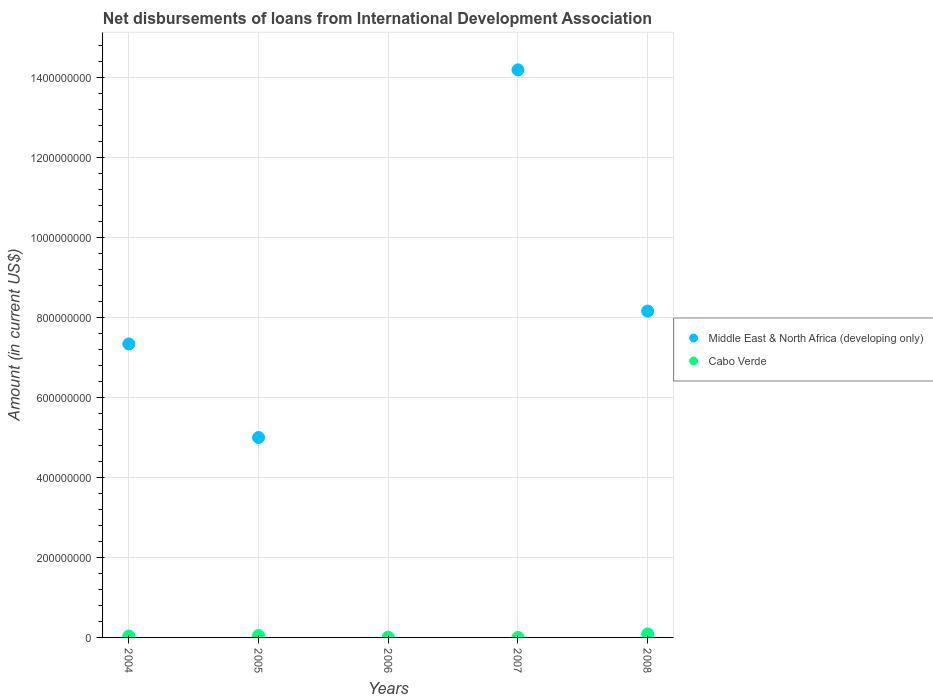How many different coloured dotlines are there?
Provide a short and direct response. 2. What is the amount of loans disbursed in Cabo Verde in 2006?
Offer a terse response. 7.69e+05. Across all years, what is the maximum amount of loans disbursed in Cabo Verde?
Make the answer very short. 8.72e+06. Across all years, what is the minimum amount of loans disbursed in Cabo Verde?
Your answer should be very brief. 0. What is the total amount of loans disbursed in Cabo Verde in the graph?
Your answer should be very brief. 1.80e+07. What is the difference between the amount of loans disbursed in Cabo Verde in 2005 and that in 2006?
Make the answer very short. 4.15e+06. What is the difference between the amount of loans disbursed in Middle East & North Africa (developing only) in 2005 and the amount of loans disbursed in Cabo Verde in 2007?
Keep it short and to the point. 5.00e+08. What is the average amount of loans disbursed in Middle East & North Africa (developing only) per year?
Provide a succinct answer. 6.94e+08. In the year 2008, what is the difference between the amount of loans disbursed in Cabo Verde and amount of loans disbursed in Middle East & North Africa (developing only)?
Make the answer very short. -8.07e+08. What is the ratio of the amount of loans disbursed in Cabo Verde in 2004 to that in 2008?
Your answer should be compact. 0.41. What is the difference between the highest and the second highest amount of loans disbursed in Middle East & North Africa (developing only)?
Your answer should be compact. 6.03e+08. What is the difference between the highest and the lowest amount of loans disbursed in Middle East & North Africa (developing only)?
Your answer should be compact. 1.42e+09. In how many years, is the amount of loans disbursed in Middle East & North Africa (developing only) greater than the average amount of loans disbursed in Middle East & North Africa (developing only) taken over all years?
Give a very brief answer. 3. Is the amount of loans disbursed in Middle East & North Africa (developing only) strictly greater than the amount of loans disbursed in Cabo Verde over the years?
Your answer should be compact. No. Are the values on the major ticks of Y-axis written in scientific E-notation?
Ensure brevity in your answer.  No. Does the graph contain any zero values?
Give a very brief answer. Yes. Where does the legend appear in the graph?
Give a very brief answer. Center right. What is the title of the graph?
Give a very brief answer. Net disbursements of loans from International Development Association. Does "Italy" appear as one of the legend labels in the graph?
Your answer should be compact. No. What is the Amount (in current US$) of Middle East & North Africa (developing only) in 2004?
Ensure brevity in your answer.  7.34e+08. What is the Amount (in current US$) in Cabo Verde in 2004?
Offer a terse response. 3.55e+06. What is the Amount (in current US$) of Middle East & North Africa (developing only) in 2005?
Your response must be concise. 5.00e+08. What is the Amount (in current US$) in Cabo Verde in 2005?
Provide a succinct answer. 4.92e+06. What is the Amount (in current US$) of Cabo Verde in 2006?
Your response must be concise. 7.69e+05. What is the Amount (in current US$) of Middle East & North Africa (developing only) in 2007?
Your answer should be very brief. 1.42e+09. What is the Amount (in current US$) of Middle East & North Africa (developing only) in 2008?
Offer a very short reply. 8.16e+08. What is the Amount (in current US$) of Cabo Verde in 2008?
Give a very brief answer. 8.72e+06. Across all years, what is the maximum Amount (in current US$) in Middle East & North Africa (developing only)?
Give a very brief answer. 1.42e+09. Across all years, what is the maximum Amount (in current US$) in Cabo Verde?
Ensure brevity in your answer.  8.72e+06. Across all years, what is the minimum Amount (in current US$) of Middle East & North Africa (developing only)?
Your answer should be very brief. 0. What is the total Amount (in current US$) in Middle East & North Africa (developing only) in the graph?
Offer a terse response. 3.47e+09. What is the total Amount (in current US$) in Cabo Verde in the graph?
Your response must be concise. 1.80e+07. What is the difference between the Amount (in current US$) of Middle East & North Africa (developing only) in 2004 and that in 2005?
Offer a terse response. 2.34e+08. What is the difference between the Amount (in current US$) of Cabo Verde in 2004 and that in 2005?
Provide a succinct answer. -1.38e+06. What is the difference between the Amount (in current US$) in Cabo Verde in 2004 and that in 2006?
Provide a succinct answer. 2.78e+06. What is the difference between the Amount (in current US$) of Middle East & North Africa (developing only) in 2004 and that in 2007?
Give a very brief answer. -6.85e+08. What is the difference between the Amount (in current US$) of Middle East & North Africa (developing only) in 2004 and that in 2008?
Offer a terse response. -8.22e+07. What is the difference between the Amount (in current US$) in Cabo Verde in 2004 and that in 2008?
Keep it short and to the point. -5.18e+06. What is the difference between the Amount (in current US$) of Cabo Verde in 2005 and that in 2006?
Offer a terse response. 4.15e+06. What is the difference between the Amount (in current US$) of Middle East & North Africa (developing only) in 2005 and that in 2007?
Offer a very short reply. -9.19e+08. What is the difference between the Amount (in current US$) in Middle East & North Africa (developing only) in 2005 and that in 2008?
Give a very brief answer. -3.16e+08. What is the difference between the Amount (in current US$) in Cabo Verde in 2005 and that in 2008?
Offer a terse response. -3.80e+06. What is the difference between the Amount (in current US$) in Cabo Verde in 2006 and that in 2008?
Give a very brief answer. -7.96e+06. What is the difference between the Amount (in current US$) in Middle East & North Africa (developing only) in 2007 and that in 2008?
Your answer should be very brief. 6.03e+08. What is the difference between the Amount (in current US$) of Middle East & North Africa (developing only) in 2004 and the Amount (in current US$) of Cabo Verde in 2005?
Your response must be concise. 7.29e+08. What is the difference between the Amount (in current US$) of Middle East & North Africa (developing only) in 2004 and the Amount (in current US$) of Cabo Verde in 2006?
Offer a terse response. 7.33e+08. What is the difference between the Amount (in current US$) of Middle East & North Africa (developing only) in 2004 and the Amount (in current US$) of Cabo Verde in 2008?
Your response must be concise. 7.25e+08. What is the difference between the Amount (in current US$) in Middle East & North Africa (developing only) in 2005 and the Amount (in current US$) in Cabo Verde in 2006?
Your answer should be compact. 4.99e+08. What is the difference between the Amount (in current US$) of Middle East & North Africa (developing only) in 2005 and the Amount (in current US$) of Cabo Verde in 2008?
Your answer should be very brief. 4.91e+08. What is the difference between the Amount (in current US$) in Middle East & North Africa (developing only) in 2007 and the Amount (in current US$) in Cabo Verde in 2008?
Ensure brevity in your answer.  1.41e+09. What is the average Amount (in current US$) in Middle East & North Africa (developing only) per year?
Offer a very short reply. 6.94e+08. What is the average Amount (in current US$) of Cabo Verde per year?
Your response must be concise. 3.59e+06. In the year 2004, what is the difference between the Amount (in current US$) of Middle East & North Africa (developing only) and Amount (in current US$) of Cabo Verde?
Provide a succinct answer. 7.30e+08. In the year 2005, what is the difference between the Amount (in current US$) in Middle East & North Africa (developing only) and Amount (in current US$) in Cabo Verde?
Your answer should be compact. 4.95e+08. In the year 2008, what is the difference between the Amount (in current US$) in Middle East & North Africa (developing only) and Amount (in current US$) in Cabo Verde?
Provide a short and direct response. 8.07e+08. What is the ratio of the Amount (in current US$) of Middle East & North Africa (developing only) in 2004 to that in 2005?
Ensure brevity in your answer.  1.47. What is the ratio of the Amount (in current US$) of Cabo Verde in 2004 to that in 2005?
Your response must be concise. 0.72. What is the ratio of the Amount (in current US$) of Cabo Verde in 2004 to that in 2006?
Make the answer very short. 4.61. What is the ratio of the Amount (in current US$) in Middle East & North Africa (developing only) in 2004 to that in 2007?
Ensure brevity in your answer.  0.52. What is the ratio of the Amount (in current US$) of Middle East & North Africa (developing only) in 2004 to that in 2008?
Ensure brevity in your answer.  0.9. What is the ratio of the Amount (in current US$) in Cabo Verde in 2004 to that in 2008?
Provide a succinct answer. 0.41. What is the ratio of the Amount (in current US$) in Cabo Verde in 2005 to that in 2006?
Provide a short and direct response. 6.4. What is the ratio of the Amount (in current US$) in Middle East & North Africa (developing only) in 2005 to that in 2007?
Your answer should be compact. 0.35. What is the ratio of the Amount (in current US$) of Middle East & North Africa (developing only) in 2005 to that in 2008?
Your response must be concise. 0.61. What is the ratio of the Amount (in current US$) in Cabo Verde in 2005 to that in 2008?
Keep it short and to the point. 0.56. What is the ratio of the Amount (in current US$) in Cabo Verde in 2006 to that in 2008?
Give a very brief answer. 0.09. What is the ratio of the Amount (in current US$) of Middle East & North Africa (developing only) in 2007 to that in 2008?
Offer a very short reply. 1.74. What is the difference between the highest and the second highest Amount (in current US$) in Middle East & North Africa (developing only)?
Make the answer very short. 6.03e+08. What is the difference between the highest and the second highest Amount (in current US$) in Cabo Verde?
Your answer should be compact. 3.80e+06. What is the difference between the highest and the lowest Amount (in current US$) in Middle East & North Africa (developing only)?
Your answer should be very brief. 1.42e+09. What is the difference between the highest and the lowest Amount (in current US$) in Cabo Verde?
Provide a succinct answer. 8.72e+06. 